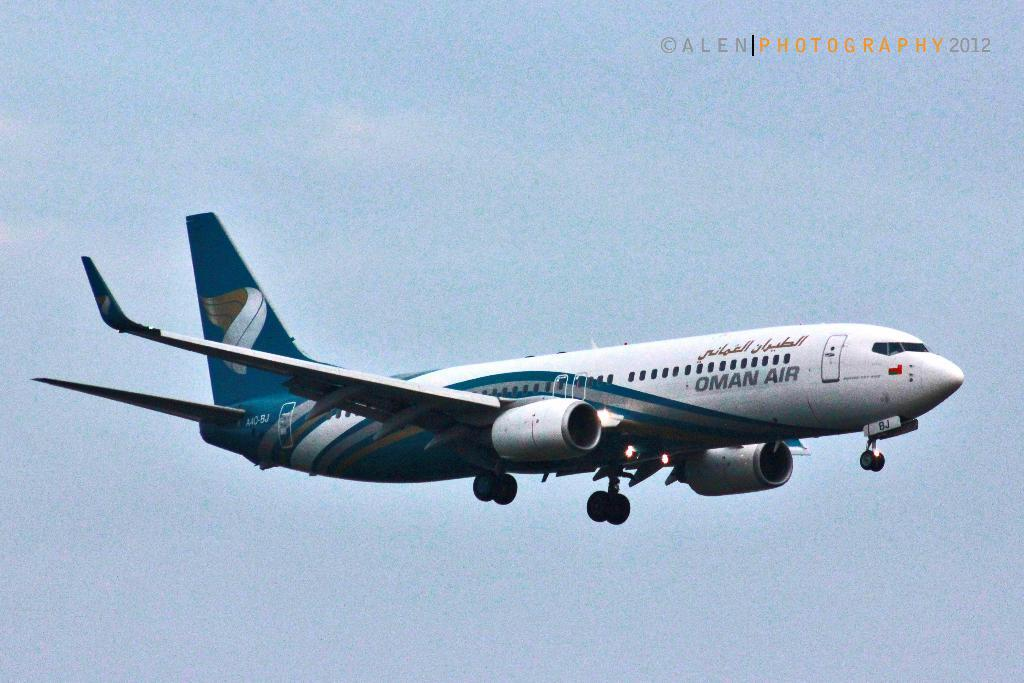What is the main subject of the image? The main subject of the image is an aeroplane. What colors can be seen on the aeroplane? The aeroplane is white and blue in color. What is the aeroplane doing in the image? The aeroplane is flying in the air. What can be seen in the background of the image? The sky is visible in the background of the image. Can you see any sparks coming from the aeroplane in the image? There are no sparks visible in the image; the aeroplane is simply flying in the air. 